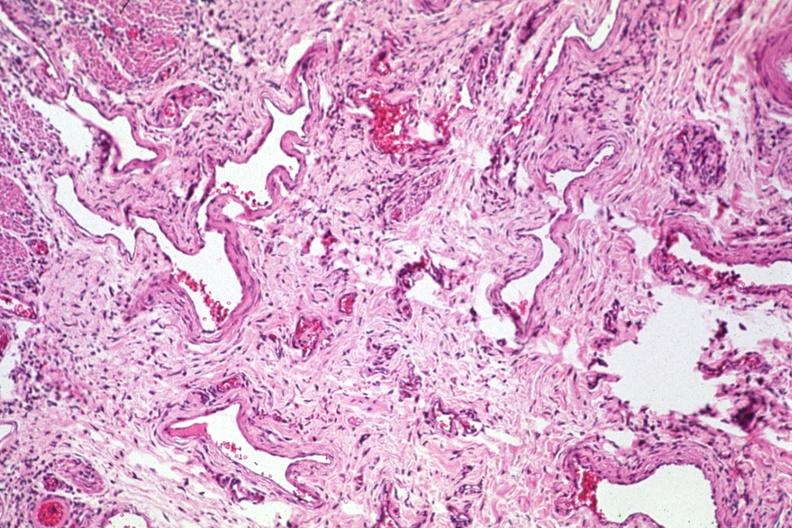s esophagus present?
Answer the question using a single word or phrase. Yes 